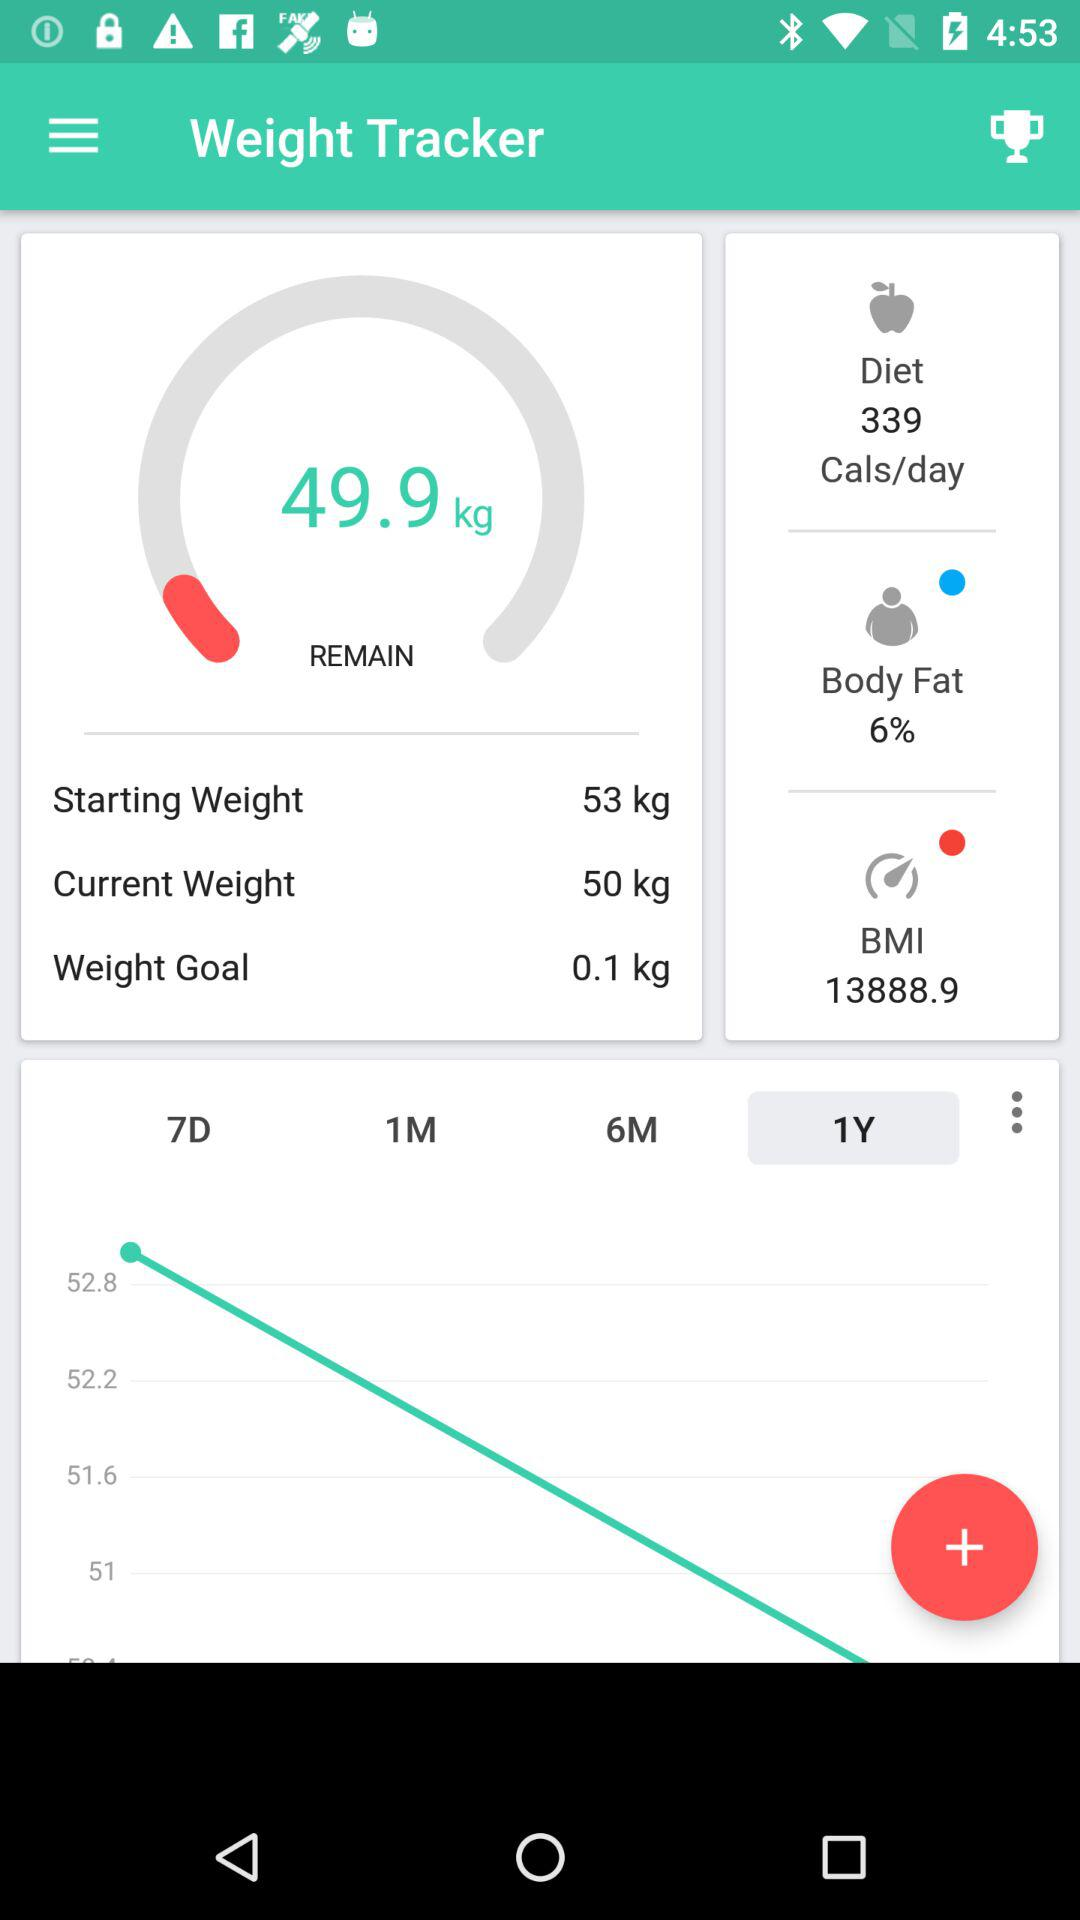What is the current weight? The current weight is 50 kg. 